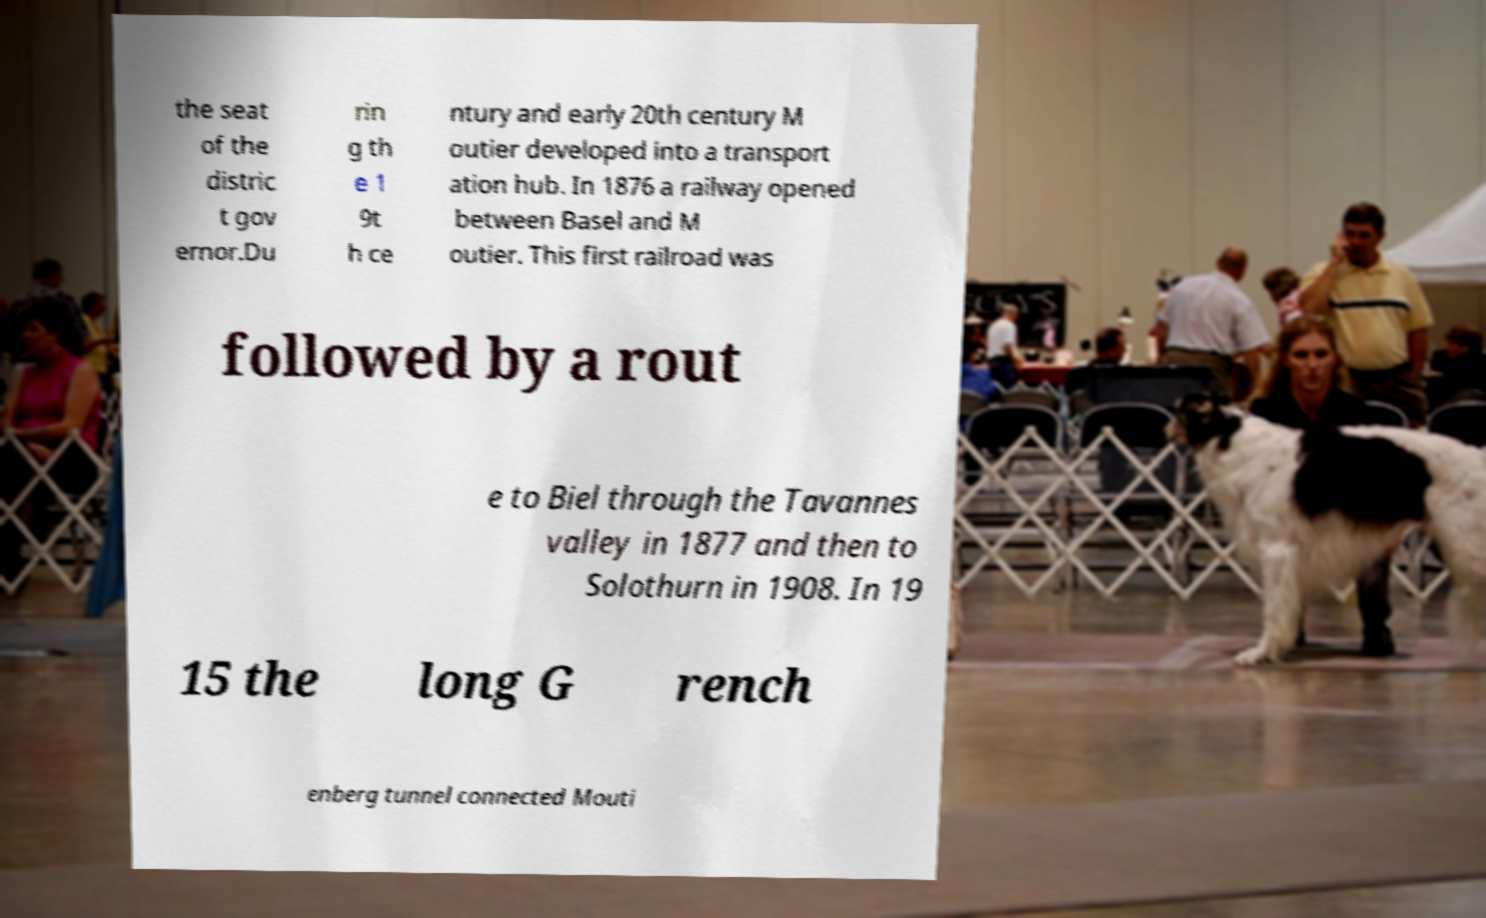For documentation purposes, I need the text within this image transcribed. Could you provide that? the seat of the distric t gov ernor.Du rin g th e 1 9t h ce ntury and early 20th century M outier developed into a transport ation hub. In 1876 a railway opened between Basel and M outier. This first railroad was followed by a rout e to Biel through the Tavannes valley in 1877 and then to Solothurn in 1908. In 19 15 the long G rench enberg tunnel connected Mouti 